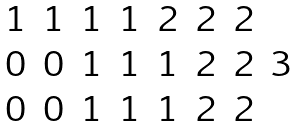<formula> <loc_0><loc_0><loc_500><loc_500>\begin{matrix} 1 & 1 & 1 & 1 & 2 & 2 & 2 & \\ 0 & 0 & 1 & 1 & 1 & 2 & 2 & 3 \\ 0 & 0 & 1 & 1 & 1 & 2 & 2 & \end{matrix}</formula> 